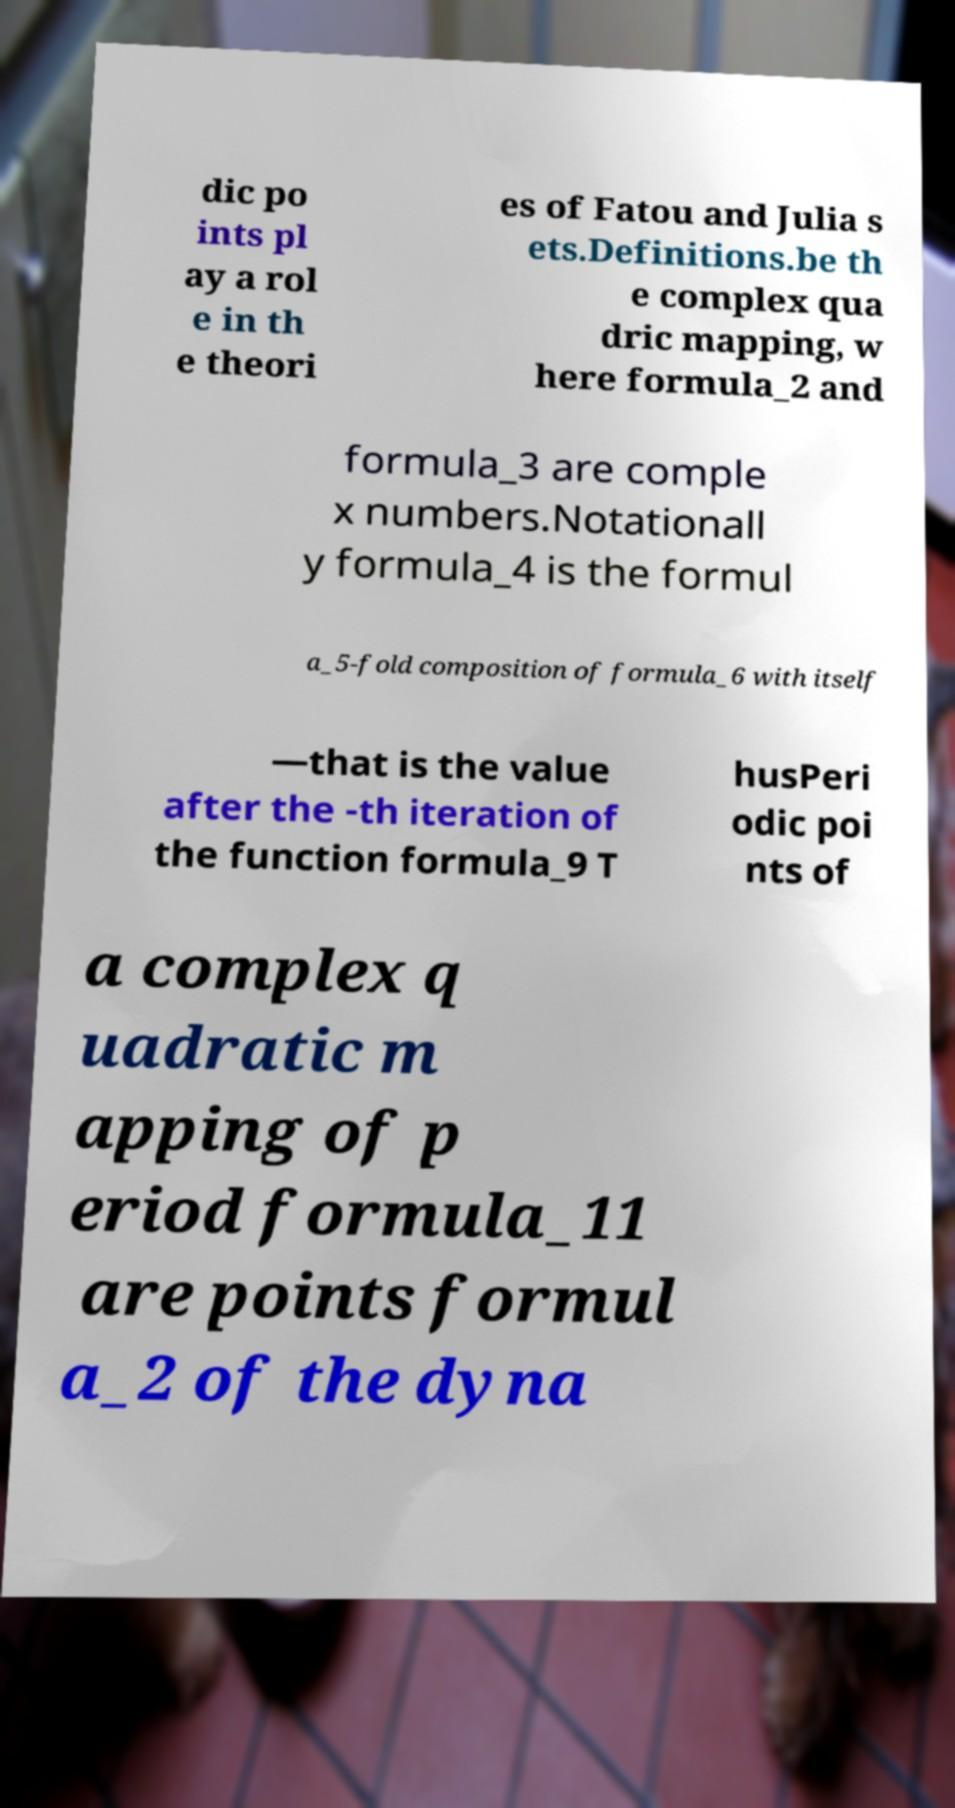Could you assist in decoding the text presented in this image and type it out clearly? dic po ints pl ay a rol e in th e theori es of Fatou and Julia s ets.Definitions.be th e complex qua dric mapping, w here formula_2 and formula_3 are comple x numbers.Notationall y formula_4 is the formul a_5-fold composition of formula_6 with itself —that is the value after the -th iteration of the function formula_9 T husPeri odic poi nts of a complex q uadratic m apping of p eriod formula_11 are points formul a_2 of the dyna 